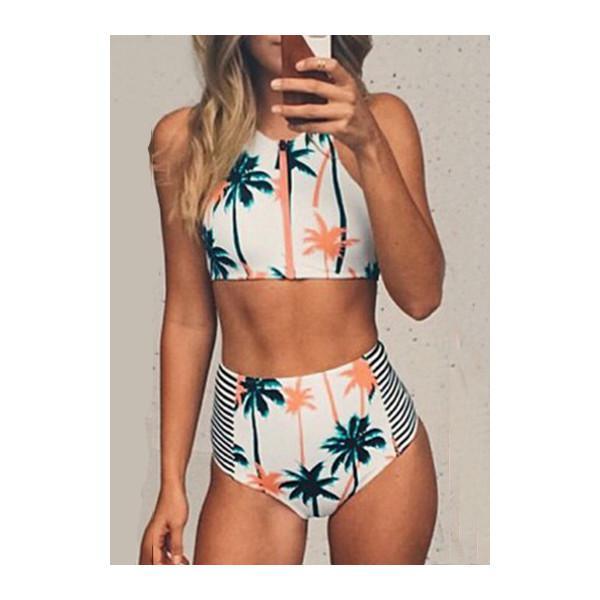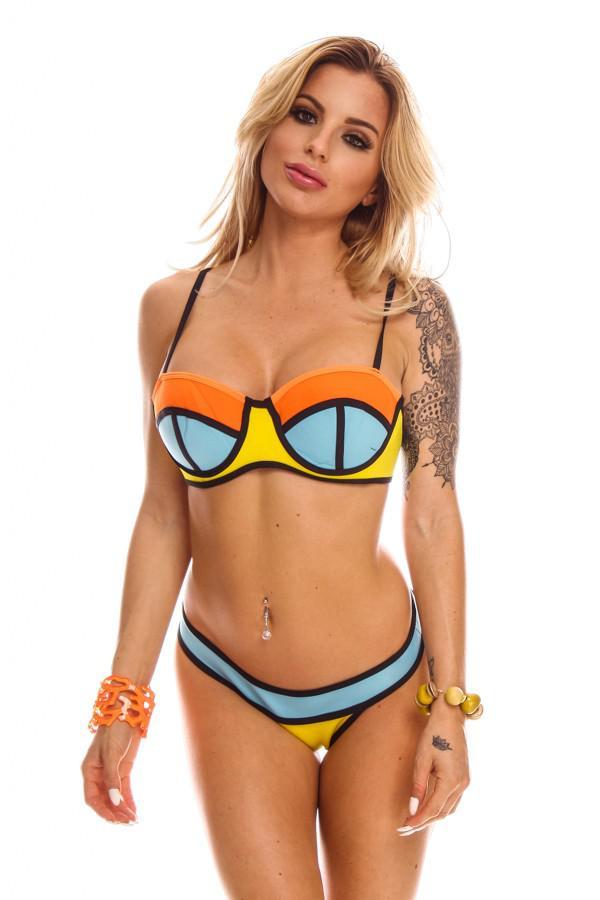The first image is the image on the left, the second image is the image on the right. Examine the images to the left and right. Is the description "At least one of the images shows a very low-rise bikini bottom that hits well below the belly button." accurate? Answer yes or no. Yes. 